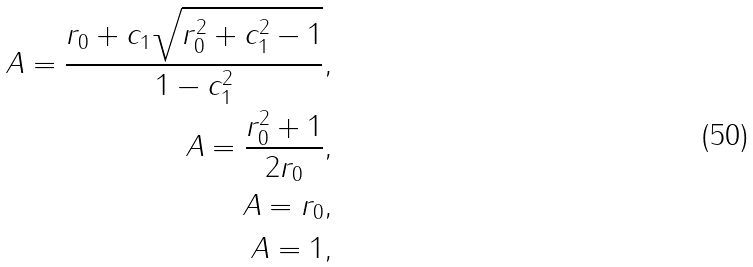Convert formula to latex. <formula><loc_0><loc_0><loc_500><loc_500>A = \frac { r _ { 0 } + c _ { 1 } \sqrt { r _ { 0 } ^ { 2 } + c _ { 1 } ^ { 2 } - 1 } } { 1 - c _ { 1 } ^ { 2 } } , \\ A = \frac { r _ { 0 } ^ { 2 } + 1 } { 2 r _ { 0 } } , \\ A = r _ { 0 } , \\ A = 1 ,</formula> 